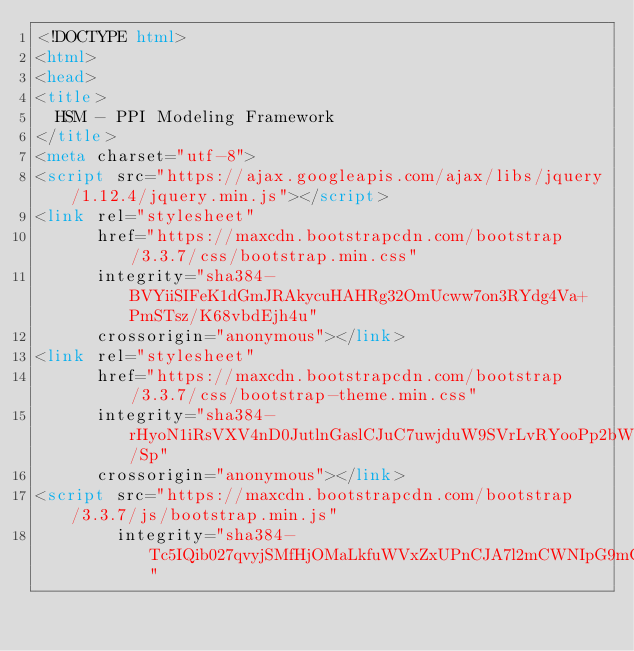<code> <loc_0><loc_0><loc_500><loc_500><_HTML_><!DOCTYPE html>
<html>
<head>
<title>
  HSM - PPI Modeling Framework
</title>
<meta charset="utf-8">
<script src="https://ajax.googleapis.com/ajax/libs/jquery/1.12.4/jquery.min.js"></script>
<link rel="stylesheet" 
      href="https://maxcdn.bootstrapcdn.com/bootstrap/3.3.7/css/bootstrap.min.css" 
      integrity="sha384-BVYiiSIFeK1dGmJRAkycuHAHRg32OmUcww7on3RYdg4Va+PmSTsz/K68vbdEjh4u" 
      crossorigin="anonymous"></link>
<link rel="stylesheet" 
      href="https://maxcdn.bootstrapcdn.com/bootstrap/3.3.7/css/bootstrap-theme.min.css" 
      integrity="sha384-rHyoN1iRsVXV4nD0JutlnGaslCJuC7uwjduW9SVrLvRYooPp2bWYgmgJQIXwl/Sp" 
      crossorigin="anonymous"></link>
<script src="https://maxcdn.bootstrapcdn.com/bootstrap/3.3.7/js/bootstrap.min.js" 
        integrity="sha384-Tc5IQib027qvyjSMfHjOMaLkfuWVxZxUPnCJA7l2mCWNIpG9mGCD8wGNIcPD7Txa" </code> 